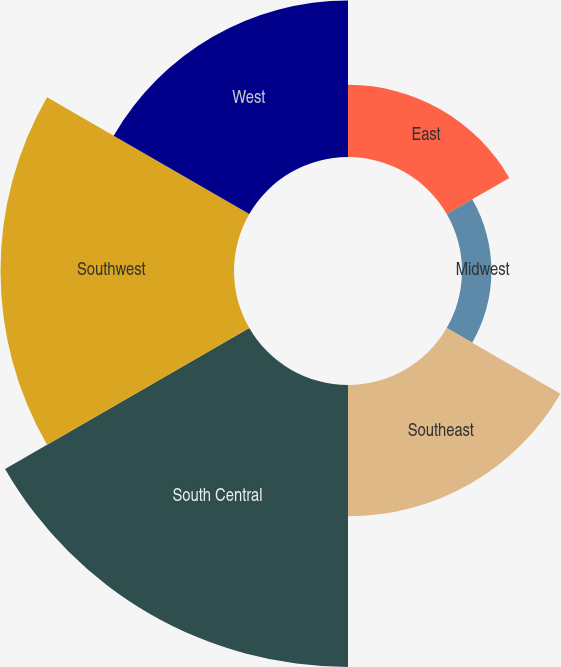Convert chart to OTSL. <chart><loc_0><loc_0><loc_500><loc_500><pie_chart><fcel>East<fcel>Midwest<fcel>Southeast<fcel>South Central<fcel>Southwest<fcel>West<nl><fcel>7.98%<fcel>3.25%<fcel>14.51%<fcel>31.16%<fcel>25.8%<fcel>17.3%<nl></chart> 